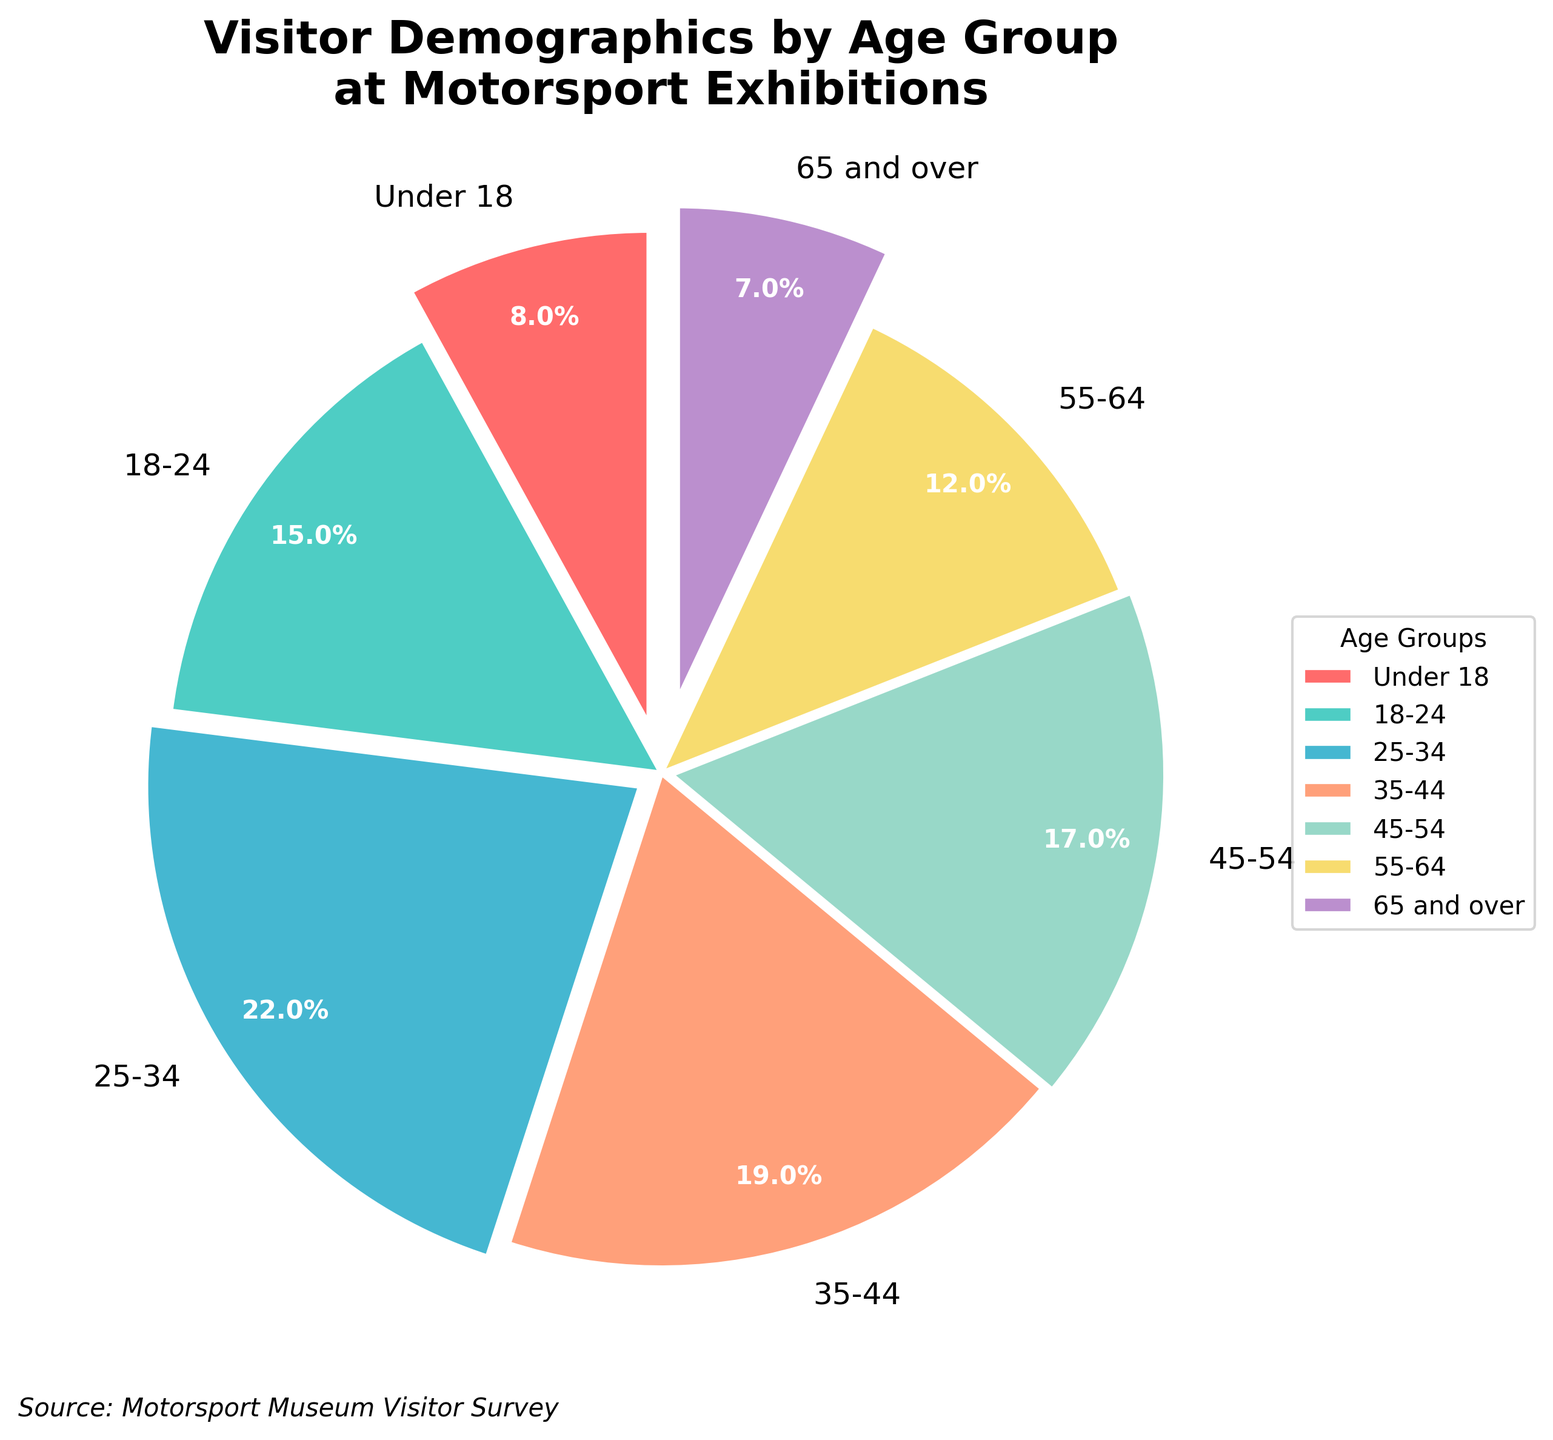What age group has the highest percentage of visitors? The figure shows the percentage breakdown for different age groups at motorsport exhibitions. The highest percentage is indicated by the largest slice of the pie chart.
Answer: 25-34 Which age groups combined make up more than half of the total visitors? The total percentage of visitors is 100%. To find out which groups make up more than 50%, we add the percentages starting from the largest slice. The 25-34 group accounts for 22%, the 35-44 group for 19%, and the 18-24 group for 15%. Adding these, we get 22% + 19% + 15% = 56%.
Answer: 18-24, 25-34, 35-44 What is the difference in visitor percentage between the 25-34 and 65 and over age groups? To find the difference between the two groups, we subtract the smaller percentage (65 and over) from the larger percentage (25-34). This is 22% - 7%.
Answer: 15% Which age group has the smallest slice in the pie chart? The smallest slice in the pie chart corresponds to the age group with the lowest percentage.
Answer: 65 and over What is the combined percentage of visitors who are under 18 and 65 and over? To find the combined percentage for these two age groups, we add their respective percentages: 8% (Under 18) + 7% (65 and over).
Answer: 15% How many age groups have a percentage higher than 15%? The age groups and their percentages are: 25-34 (22%), 35-44 (19%), and 18-24 (15%). Only the 25-34 and 35-44 groups have percentages higher than 15%.
Answer: 2 What is the average percentage of visitors for the age groups 45-54 and 55-64? To find the average percentage, we sum the two percentages and divide by 2: (17% + 12%) / 2.
Answer: 14.5% Which age group has a bigger slice, 18-24 or 45-54? By comparing the individual percentages, 18-24 has 15% and 45-54 has 17%. The 45-54 group has a bigger slice.
Answer: 45-54 What is the percentage difference between the 35-44 and 55-64 age groups? The difference is found by subtracting the percentage of the 55-64 group from the percentage of the 35-44 group: 19% - 12%.
Answer: 7% Is the sum of the visitor percentages for the age groups under 18 and 18-24 greater than the percentage for the 25-34 age group? Adding the percentages for Under 18 (8%) and 18-24 (15%) gives us 8% + 15% = 23%, which is greater than the 25-34 age group's 22%.
Answer: Yes 